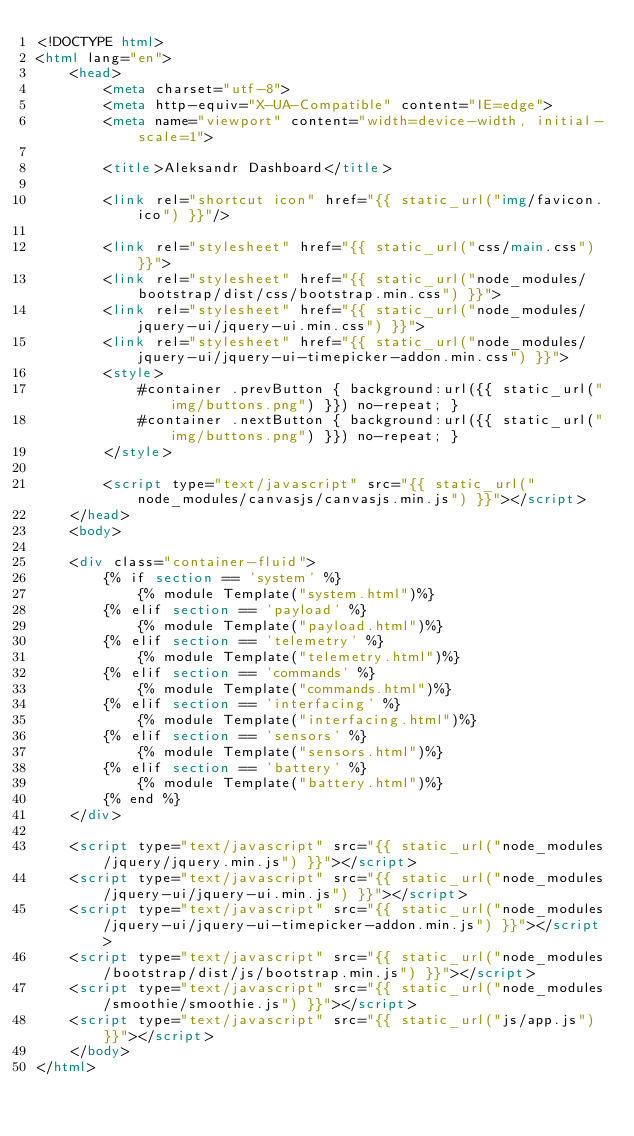<code> <loc_0><loc_0><loc_500><loc_500><_HTML_><!DOCTYPE html>
<html lang="en">
    <head>
        <meta charset="utf-8">
        <meta http-equiv="X-UA-Compatible" content="IE=edge">
        <meta name="viewport" content="width=device-width, initial-scale=1">

        <title>Aleksandr Dashboard</title>

        <link rel="shortcut icon" href="{{ static_url("img/favicon.ico") }}"/>

        <link rel="stylesheet" href="{{ static_url("css/main.css") }}">
        <link rel="stylesheet" href="{{ static_url("node_modules/bootstrap/dist/css/bootstrap.min.css") }}">
        <link rel="stylesheet" href="{{ static_url("node_modules/jquery-ui/jquery-ui.min.css") }}">
        <link rel="stylesheet" href="{{ static_url("node_modules/jquery-ui/jquery-ui-timepicker-addon.min.css") }}">
        <style>
            #container .prevButton { background:url({{ static_url("img/buttons.png") }}) no-repeat; }
            #container .nextButton { background:url({{ static_url("img/buttons.png") }}) no-repeat; }
        </style>

        <script type="text/javascript" src="{{ static_url("node_modules/canvasjs/canvasjs.min.js") }}"></script>
    </head>
    <body>

    <div class="container-fluid">
        {% if section == 'system' %}
            {% module Template("system.html")%}
        {% elif section == 'payload' %}
            {% module Template("payload.html")%}
        {% elif section == 'telemetry' %}
            {% module Template("telemetry.html")%}
        {% elif section == 'commands' %}
            {% module Template("commands.html")%}
        {% elif section == 'interfacing' %}
            {% module Template("interfacing.html")%}
        {% elif section == 'sensors' %}
            {% module Template("sensors.html")%}
        {% elif section == 'battery' %}
            {% module Template("battery.html")%}
        {% end %}
    </div>

    <script type="text/javascript" src="{{ static_url("node_modules/jquery/jquery.min.js") }}"></script>
    <script type="text/javascript" src="{{ static_url("node_modules/jquery-ui/jquery-ui.min.js") }}"></script>
    <script type="text/javascript" src="{{ static_url("node_modules/jquery-ui/jquery-ui-timepicker-addon.min.js") }}"></script>
    <script type="text/javascript" src="{{ static_url("node_modules/bootstrap/dist/js/bootstrap.min.js") }}"></script>
    <script type="text/javascript" src="{{ static_url("node_modules/smoothie/smoothie.js") }}"></script>
    <script type="text/javascript" src="{{ static_url("js/app.js") }}"></script>
    </body>
</html>
</code> 